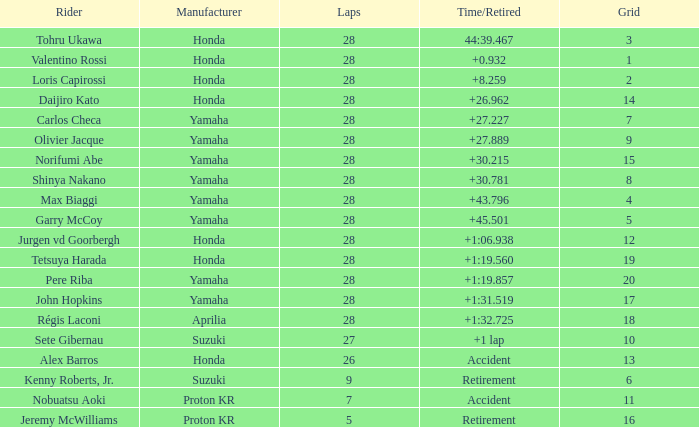In grid 4, what was the total number of laps? 28.0. 